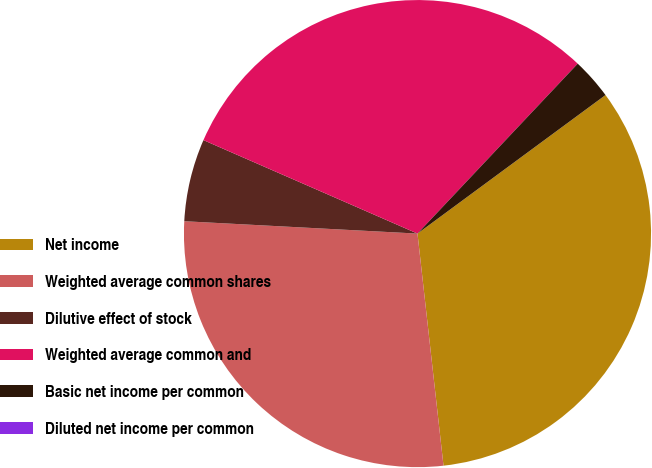<chart> <loc_0><loc_0><loc_500><loc_500><pie_chart><fcel>Net income<fcel>Weighted average common shares<fcel>Dilutive effect of stock<fcel>Weighted average common and<fcel>Basic net income per common<fcel>Diluted net income per common<nl><fcel>33.33%<fcel>27.62%<fcel>5.71%<fcel>30.48%<fcel>2.86%<fcel>0.0%<nl></chart> 